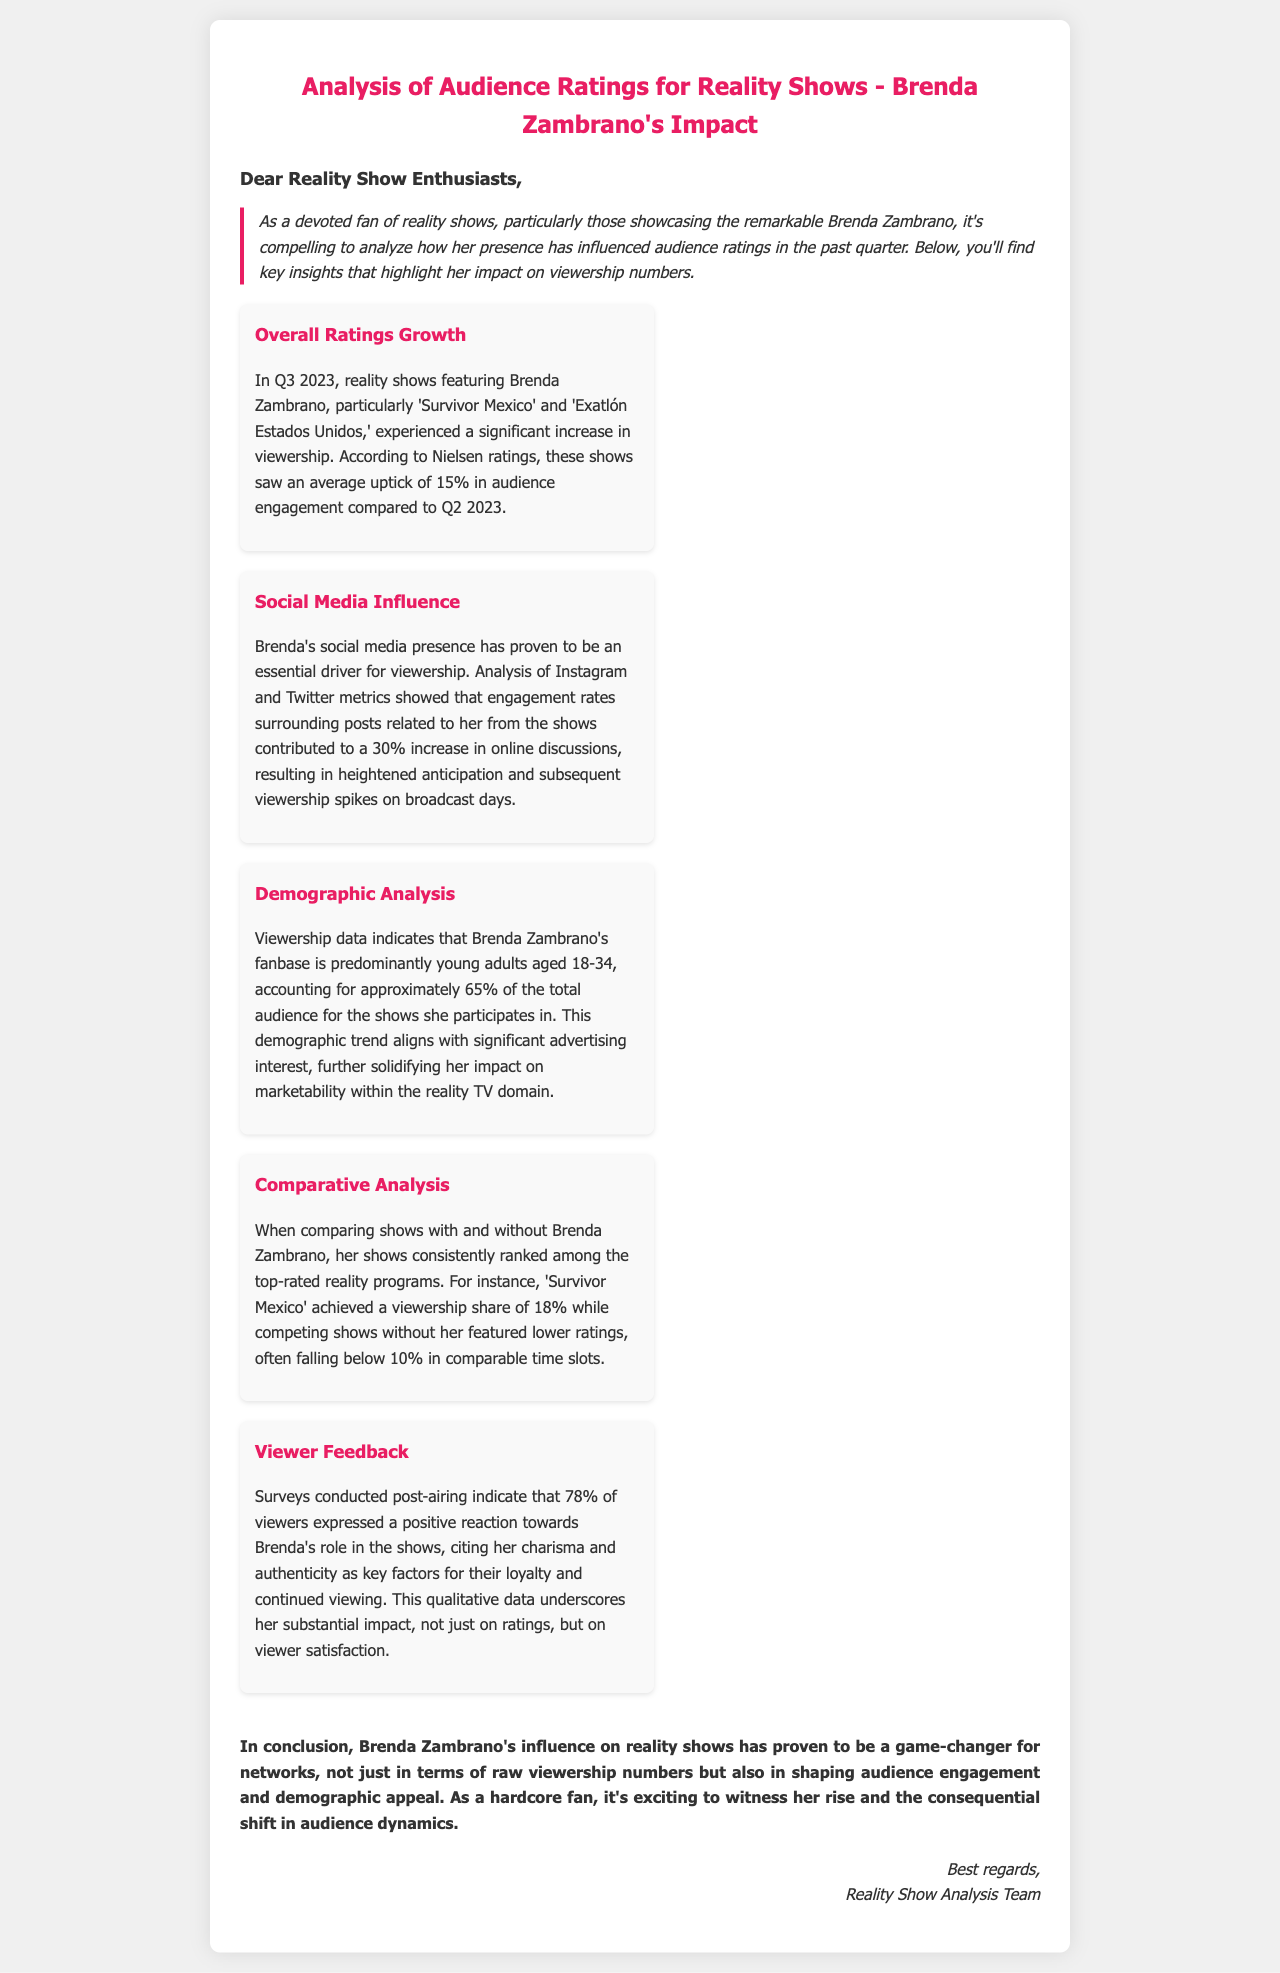what shows featured Brenda Zambrano in Q3 2023? The shows highlighted are 'Survivor Mexico' and 'Exatlón Estados Unidos.'
Answer: 'Survivor Mexico' and 'Exatlón Estados Unidos' what was the increase in audience engagement for Brenda's shows in Q3 2023? The document mentions a 15% increase in audience engagement compared to Q2 2023.
Answer: 15% what demographic accounts for 65% of Brenda's show's audience? The document states that young adults aged 18-34 represent this demographic.
Answer: young adults aged 18-34 how much did online discussions increase due to Brenda's social media influence? The text indicates a 30% increase in online discussions surrounding posts related to her shows.
Answer: 30% what percentage of viewers had a positive reaction towards Brenda's role? The document states that 78% of viewers expressed a positive reaction.
Answer: 78% what was the viewership share for 'Survivor Mexico'? The document notes that 'Survivor Mexico' achieved a viewership share of 18%.
Answer: 18% how do shows with Brenda compare to shows without her in terms of ratings? The document indicates that shows with Brenda consistently ranked higher, often over 10%.
Answer: consistently ranked higher what role did viewer feedback play in Brenda's impact on ratings? The surveys indicate that viewers cited Brenda's charisma and authenticity as key factors for their loyalty and continued viewing.
Answer: charisma and authenticity what is the conclusion about Brenda Zambrano's influence in reality shows? The conclusion highlights that her influence is a game-changer for networks in terms of viewership and audience engagement.
Answer: game-changer for networks 